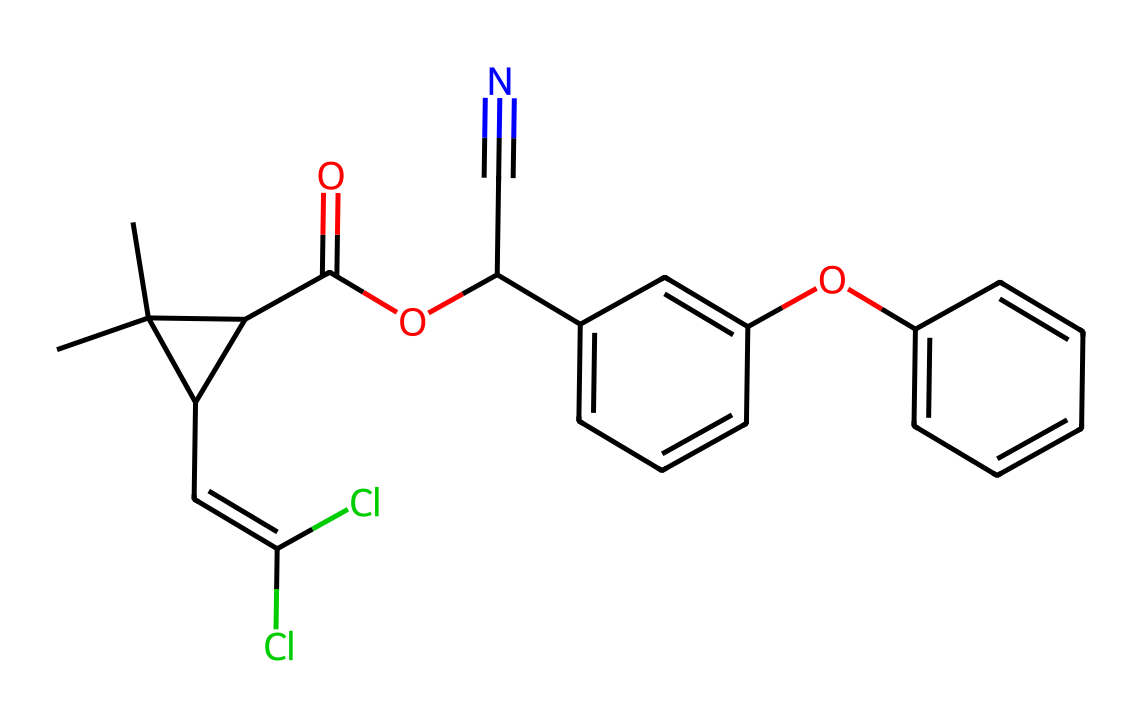What is the molecular formula of permethrin? To determine the molecular formula from the SMILES representation, we analyze the atoms. The structure contains carbon (C), hydrogen (H), nitrogen (N), chlorine (Cl), and oxygen (O) atoms. After counting each type of atom, we find 21 carbons, 23 hydrogens, 1 nitrogen, 2 chlorines, and 3 oxygens. Thus, the molecular formula is C21H23Cl2N2O3.
Answer: C21H23Cl2N2O3 How many rings are present in the structure of permethrin? By examining the SMILES representation, we identify the occurrences of ring closures, represented generally by numbers adjacent to the atoms. There are no numerical indicators in the structure, indicating that there are no rings present in permethrin.
Answer: 0 Which functional groups are present in the permethrin structure? Examining the structure involves looking for specific arrangements of atoms that indicate functional groups. The presence of a carbonyl group (C=O), an ether (–O–), a nitrile group (–C≡N), and aromatic groups (specifically phenyl rings) indicates several functional groups.
Answer: carbonyl, ether, nitrile, aromatic What is the predominant type of pesticide represented by permethrin? Understanding permethrin’s classification involves recognizing its application primarily against insects, specifically as a synthetic pyrethroid, which mimics the effects of pyrethrins—natural insecticides. Thus, it's predominantly an insecticide.
Answer: insecticide Does permethrin contain any halogen atoms? In the structure, the presence of a chlorine atom (Cl) can be verified in the SMILES notation where (Cl) appears. Chlorine is a halogen, confirming that permethrin does contain halogen atoms.
Answer: yes 